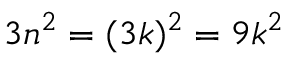Convert formula to latex. <formula><loc_0><loc_0><loc_500><loc_500>3 n ^ { 2 } = ( 3 k ) ^ { 2 } = 9 k ^ { 2 }</formula> 